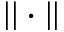<formula> <loc_0><loc_0><loc_500><loc_500>| | \cdot | |</formula> 